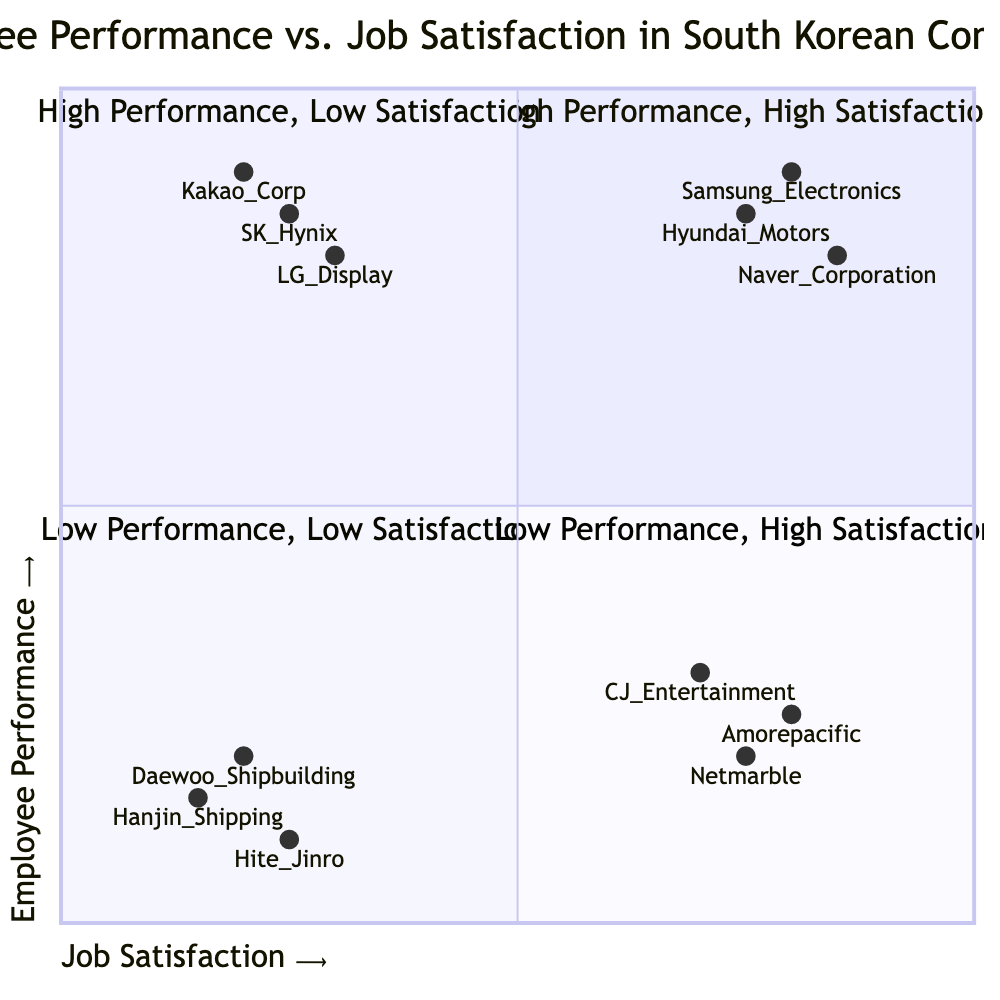What are the companies in the "High Performance, High Satisfaction" quadrant? The "High Performance, High Satisfaction" quadrant includes Samsung Electronics, Hyundai Motors, and Naver Corporation, which are listed as examples in this quadrant.
Answer: Samsung Electronics, Hyundai Motors, Naver Corporation Which quadrant contains the company "LG Display"? LG Display is categorized in the "High Performance, Low Satisfaction" quadrant, as indicated by the quadrant label and its characteristics.
Answer: High Performance, Low Satisfaction How many companies are in the "Low Performance, Low Satisfaction" quadrant? The "Low Performance, Low Satisfaction" quadrant has three companies listed: Daewoo Shipbuilding, Hanjin Shipping, and Hite Jinro. This indicates that there are three examples of companies in this quadrant.
Answer: 3 What characteristic is common in the "High Performance, Low Satisfaction" quadrant? A common characteristic in the "High Performance, Low Satisfaction" quadrant is "High Workload," which reflects one of the negative aspects affecting job satisfaction despite high performance.
Answer: High Workload Which quadrant shows a relaxed work environment? The "Low Performance, High Satisfaction" quadrant displays a relaxed work environment as one of its characteristics, which affects job satisfaction positively while performance is low.
Answer: Low Performance, High Satisfaction Which company has the lowest job satisfaction? The company with the lowest job satisfaction, represented by the coordinate [0.15, 0.15], is Hanjin Shipping, which signifies it is located at the bottom-left of the quadrant chart.
Answer: Hanjin Shipping What is the primary factor that differentiates the two high-performance quadrants? The primary differentiating factor between the two high-performance quadrants is job satisfaction; the "High Performance, High Satisfaction" quadrant has high satisfaction, while the "High Performance, Low Satisfaction" quadrant has low satisfaction despite high performance.
Answer: Job Satisfaction Which company has a strong association with high innovation and leadership practices? Samsung Electronics is known for its strong association with high innovation and leadership practices, placing it in the "High Performance, High Satisfaction" quadrant.
Answer: Samsung Electronics 